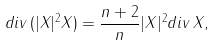<formula> <loc_0><loc_0><loc_500><loc_500>d i v \, ( | X | ^ { 2 } X ) = \frac { n + 2 } { n } | X | ^ { 2 } d i v \, X ,</formula> 